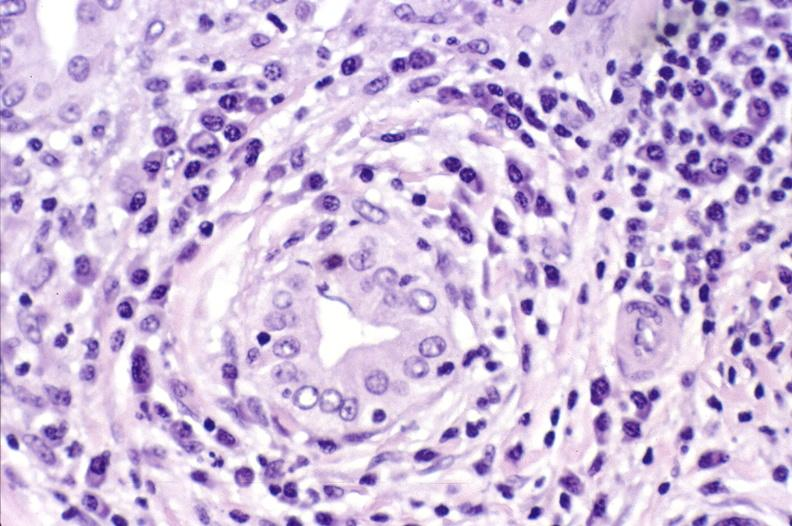does this image show primary biliary cirrhosis?
Answer the question using a single word or phrase. Yes 